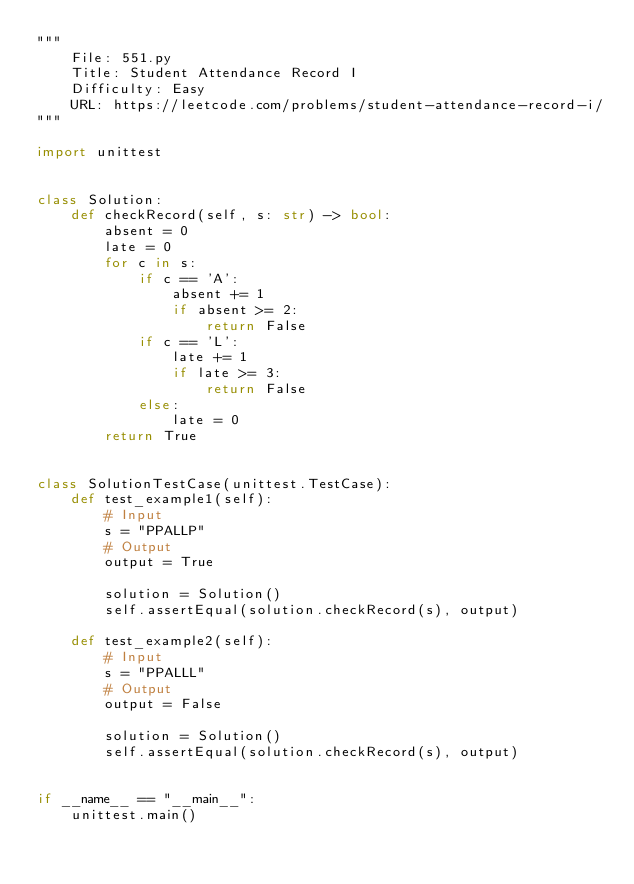Convert code to text. <code><loc_0><loc_0><loc_500><loc_500><_Python_>"""
    File: 551.py
    Title: Student Attendance Record I
    Difficulty: Easy
    URL: https://leetcode.com/problems/student-attendance-record-i/
"""

import unittest


class Solution:
    def checkRecord(self, s: str) -> bool:
        absent = 0
        late = 0
        for c in s:
            if c == 'A':
                absent += 1
                if absent >= 2:
                    return False
            if c == 'L':
                late += 1
                if late >= 3:
                    return False
            else:
                late = 0
        return True


class SolutionTestCase(unittest.TestCase):
    def test_example1(self):
        # Input
        s = "PPALLP"
        # Output
        output = True

        solution = Solution()
        self.assertEqual(solution.checkRecord(s), output)

    def test_example2(self):
        # Input
        s = "PPALLL"
        # Output
        output = False

        solution = Solution()
        self.assertEqual(solution.checkRecord(s), output)


if __name__ == "__main__":
    unittest.main()
</code> 